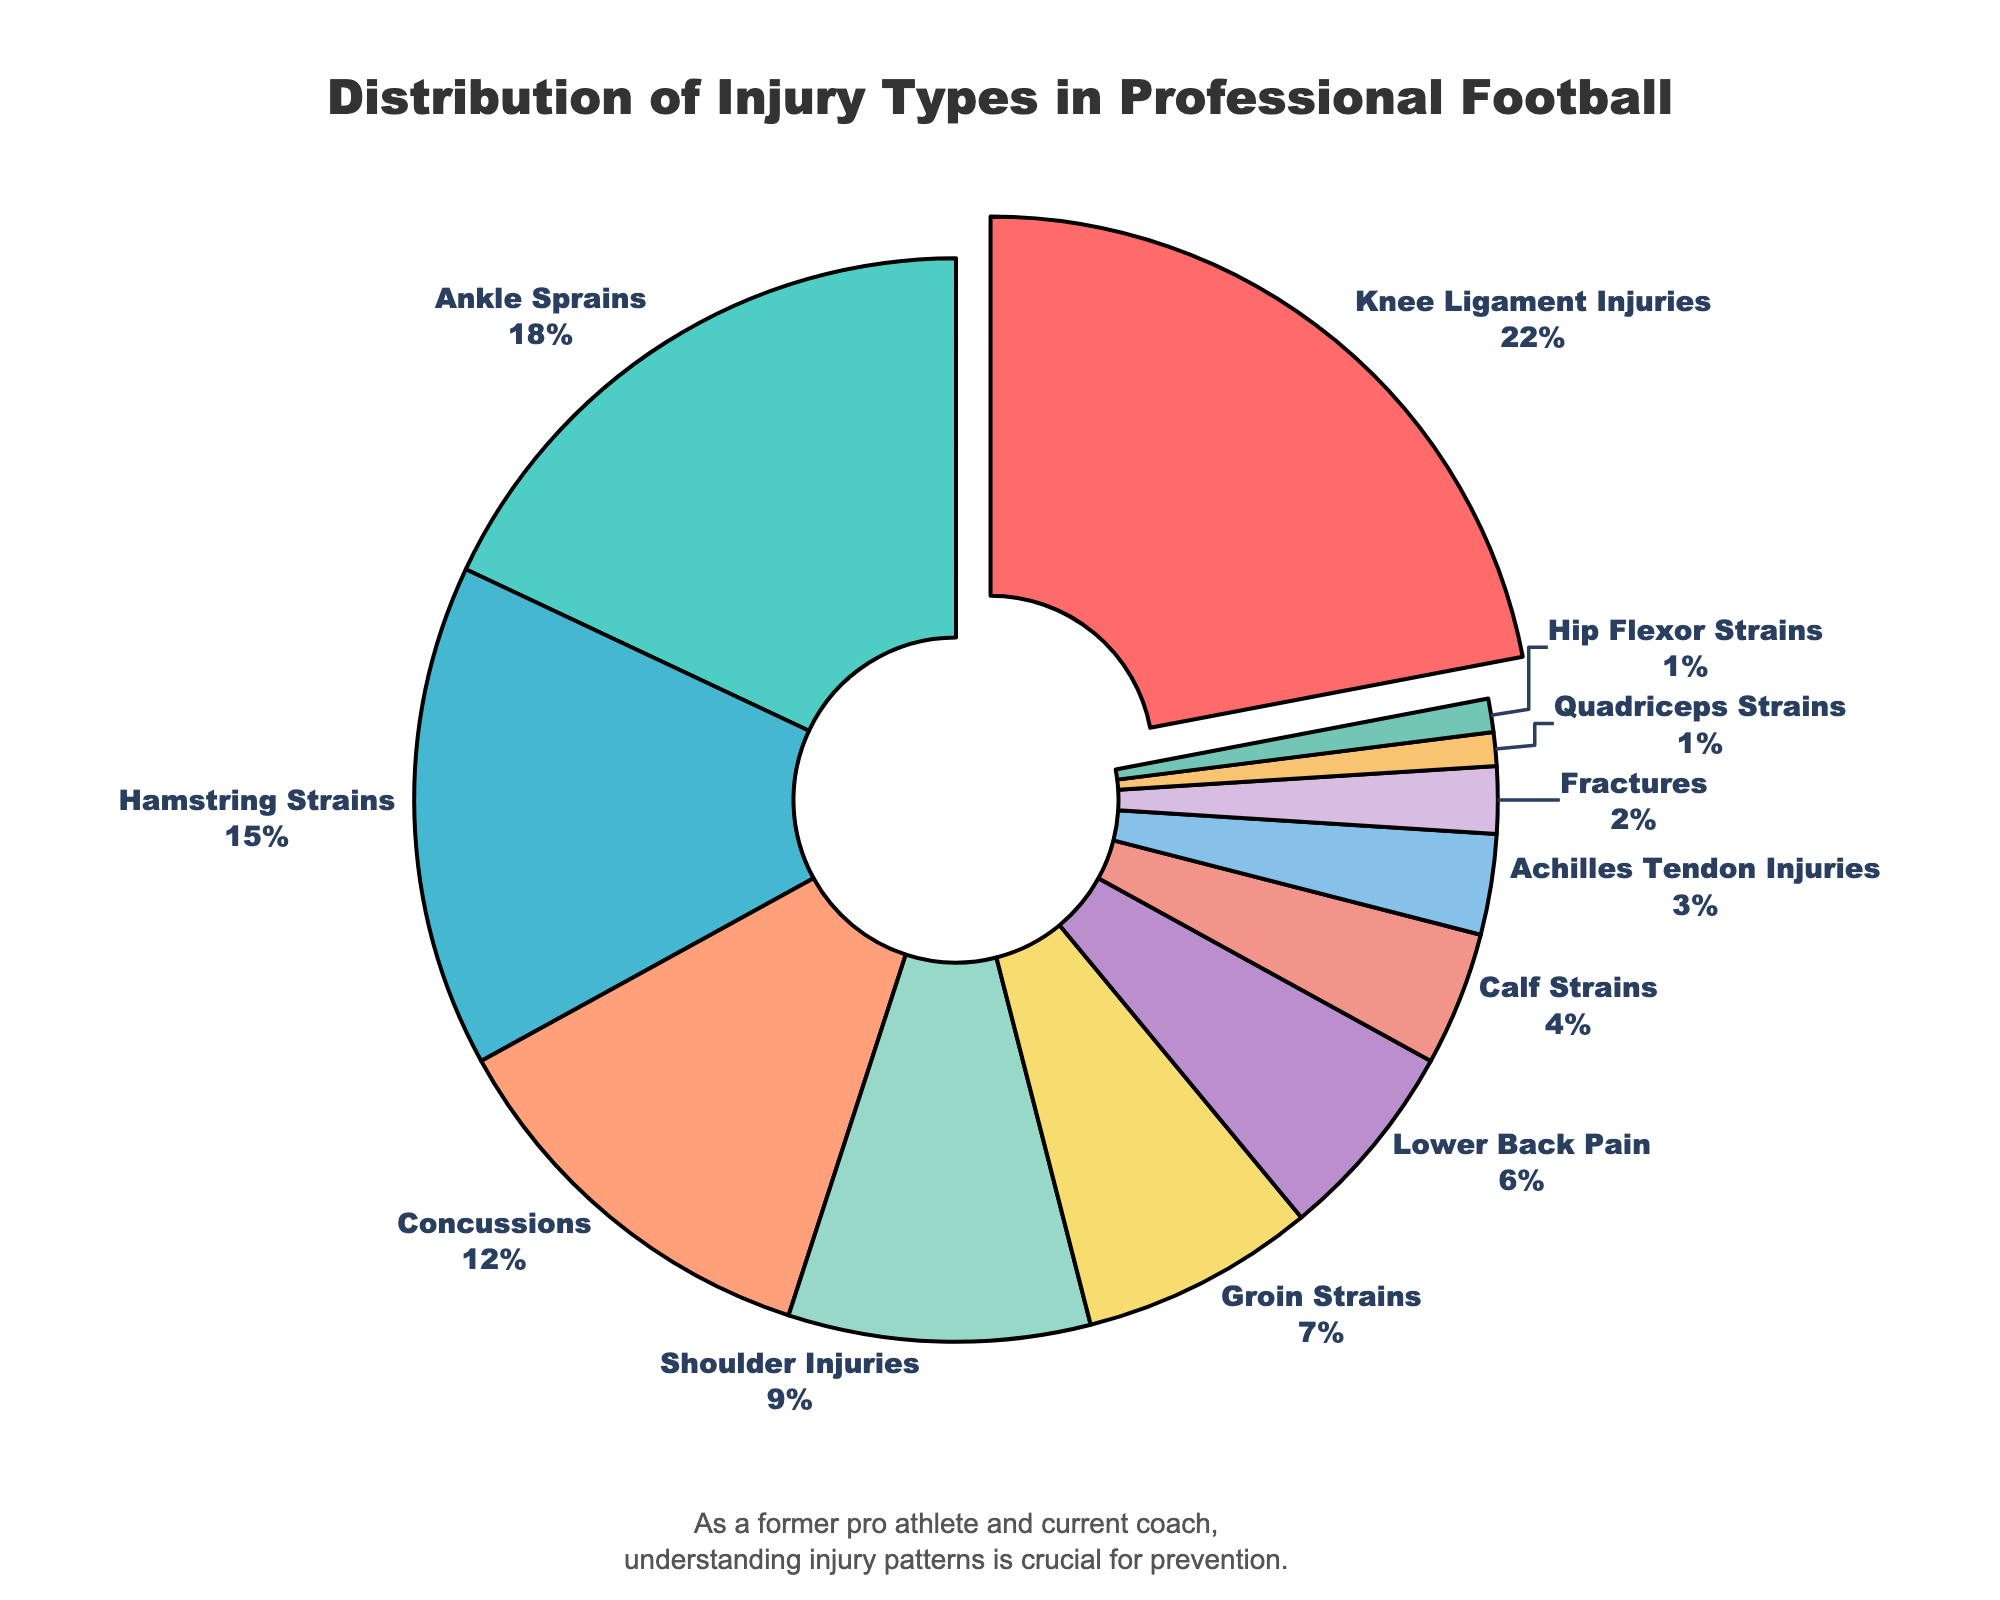What percentage of injuries are Knee Ligament Injuries? The pie chart shows that Knee Ligament Injuries account for 22% of the total injuries among professional football players.
Answer: 22% What's the combined percentage of Hamstring Strains and Ankle Sprains? According to the chart, Hamstring Strains account for 15% and Ankle Sprains account for 18%. Adding these two percentages: 15% + 18% = 33%
Answer: 33% Which injury type is the least common according to the chart? The injury types with the smallest percentages, each at 1%, are Quadriceps Strains and Hip Flexor Strains.
Answer: Quadriceps Strains and Hip Flexor Strains How much more common are Knee Ligament Injuries compared to Calf Strains? Knee Ligament Injuries are 22% and Calf Strains are 4%. The difference is 22% - 4% = 18%.
Answer: 18% What is the total percentage of all injury types related to the lower body (knee, ankle, hamstring, groin, calf, Achilles tendon, quadriceps, hip flexor)? Sum the percentages of lower body injuries: Knee Ligament (22%) + Ankle Sprains (18%) + Hamstring Strains (15%) + Groin Strains (7%) + Calf Strains (4%) + Achilles Tendon Injuries (3%) + Quadriceps Strains (1%) + Hip Flexor Strains (1%) = 71%
Answer: 71% Which injury type is represented by the largest segment in the pie chart? The largest segment in the pie chart is for Knee Ligament Injuries, which is highlighted by being slightly pulled out.
Answer: Knee Ligament Injuries How do Concussions compare in percentage to Shoulder Injuries? Concussions account for 12% of injuries, while Shoulder Injuries account for 9%. Therefore, Concussions are 3% more common than Shoulder Injuries.
Answer: 3% Among the injuries listed, how many types of injuries account for less than 5% each? The injury types contributing less than 5% are Calf Strains (4%), Achilles Tendon Injuries (3%), Fractures (2%), Quadriceps Strains (1%), and Hip Flexor Strains (1%), totaling 5 injury types.
Answer: 5 What visual indicator is used to highlight the most common injury type on the chart? The most common injury type, Knee Ligament Injuries, is visually highlighted by being slightly pulled out from the rest of the pie chart segments.
Answer: Pulled out How does the percentage of Shoulder Injuries compare with the combined percentage of Lower Back Pain and Groin Strains? Shoulder Injuries account for 9%, while Lower Back Pain is 6% and Groin Strains are 7%. Combined, Lower Back Pain and Groin Strains total 6% + 7% = 13%. Shoulder Injuries are 4% less than this combined group.
Answer: 4% less 